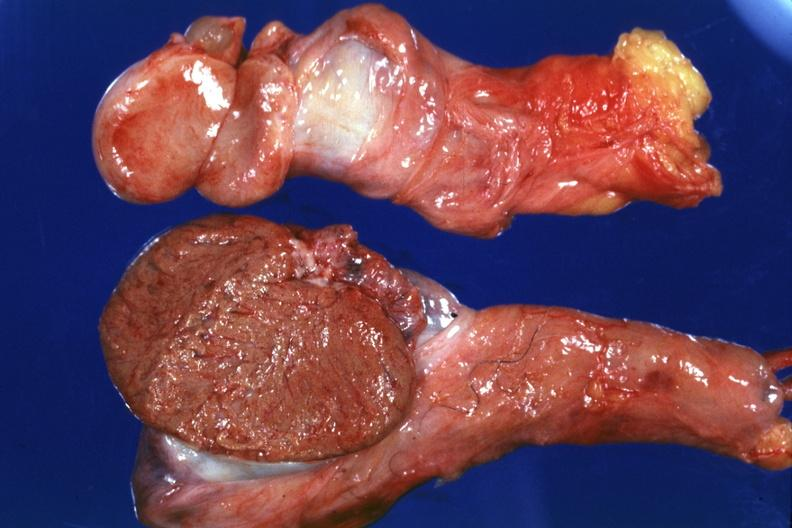what does this image show?
Answer the question using a single word or phrase. That cut surface both testicles on normal and one quite small typical probably due to mumps have no history at time 